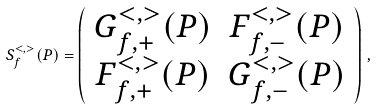Convert formula to latex. <formula><loc_0><loc_0><loc_500><loc_500>S _ { f } ^ { < , > } ( P ) = \left ( \begin{array} { c c } G _ { f , + } ^ { < , > } ( P ) & F _ { f , - } ^ { < , > } ( P ) \\ F _ { f , + } ^ { < , > } ( P ) & G _ { f , - } ^ { < , > } ( P ) \end{array} \right ) \, ,</formula> 